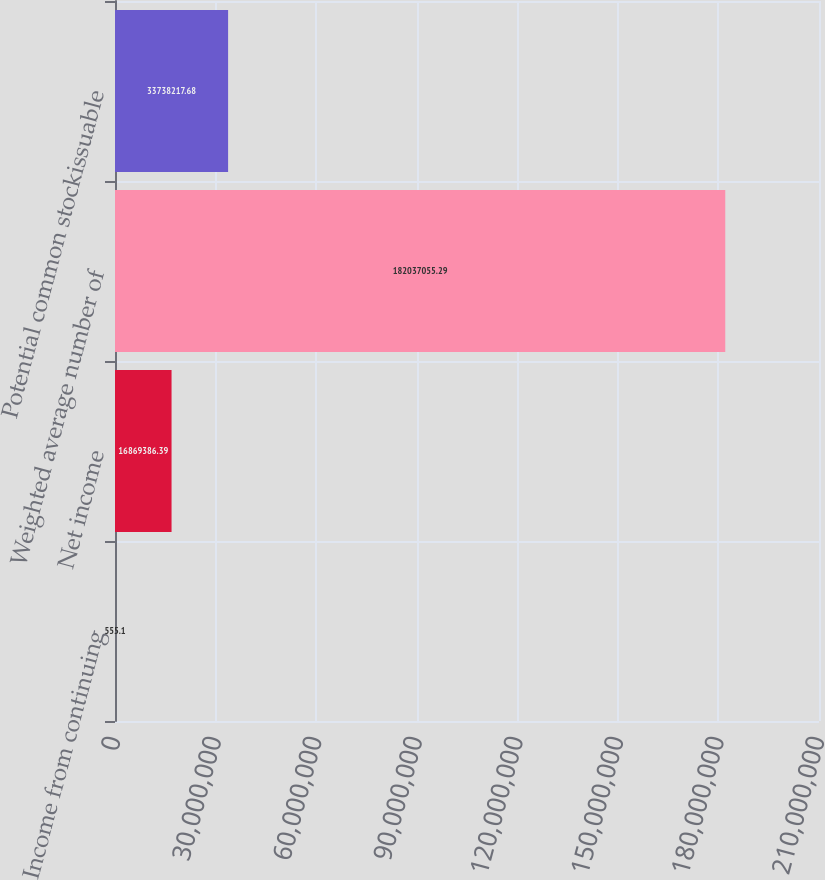Convert chart to OTSL. <chart><loc_0><loc_0><loc_500><loc_500><bar_chart><fcel>Income from continuing<fcel>Net income<fcel>Weighted average number of<fcel>Potential common stockissuable<nl><fcel>555.1<fcel>1.68694e+07<fcel>1.82037e+08<fcel>3.37382e+07<nl></chart> 